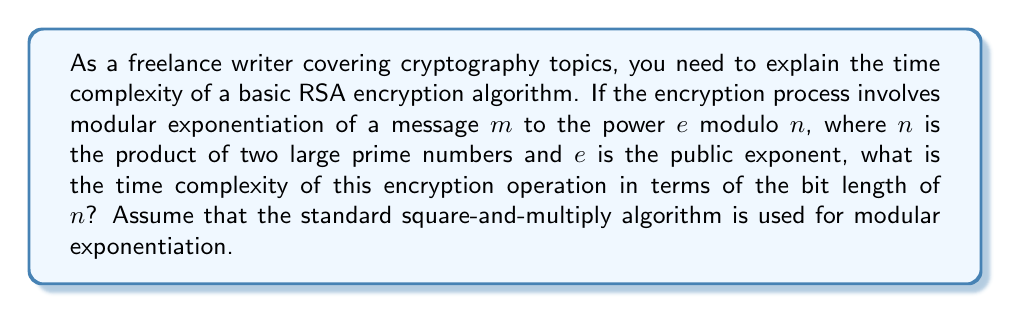Help me with this question. To determine the time complexity of the basic RSA encryption algorithm, we need to analyze the main operation: modular exponentiation.

1. In RSA encryption, we compute $c = m^e \bmod n$, where:
   - $m$ is the message
   - $e$ is the public exponent
   - $n$ is the modulus (product of two large primes)

2. The square-and-multiply algorithm is typically used for efficient modular exponentiation. Let's analyze its complexity:

   a. The algorithm processes the bits of the exponent $e$ from left to right.
   b. For each bit, it performs a squaring operation.
   c. For each '1' bit, it also performs a multiplication.

3. The number of operations depends on the bit length of $n$, let's call it $k$. This is because:
   - The exponent $e$ is typically chosen to be much smaller than $n$.
   - The modular operations are performed with respect to $n$.

4. In the worst case (when $e$ is close to $n$ in value):
   - Number of squaring operations: $k$
   - Number of multiplication operations: up to $k$

5. Each modular multiplication or squaring operation has a time complexity of $O(k^2)$ using the naive multiplication algorithm, or $O(k \log k \log \log k)$ using more advanced methods like Karatsuba multiplication.

6. Therefore, the total time complexity is:
   $$O(k \cdot k^2) = O(k^3)$$ using naive multiplication, or
   $$O(k \cdot k \log k \log \log k) = O(k^2 \log k \log \log k)$$ using advanced methods.

7. In Big O notation, we typically express this as $O(k^3)$, which represents the upper bound of the time complexity.
Answer: $O(k^3)$, where $k$ is the bit length of $n$. 